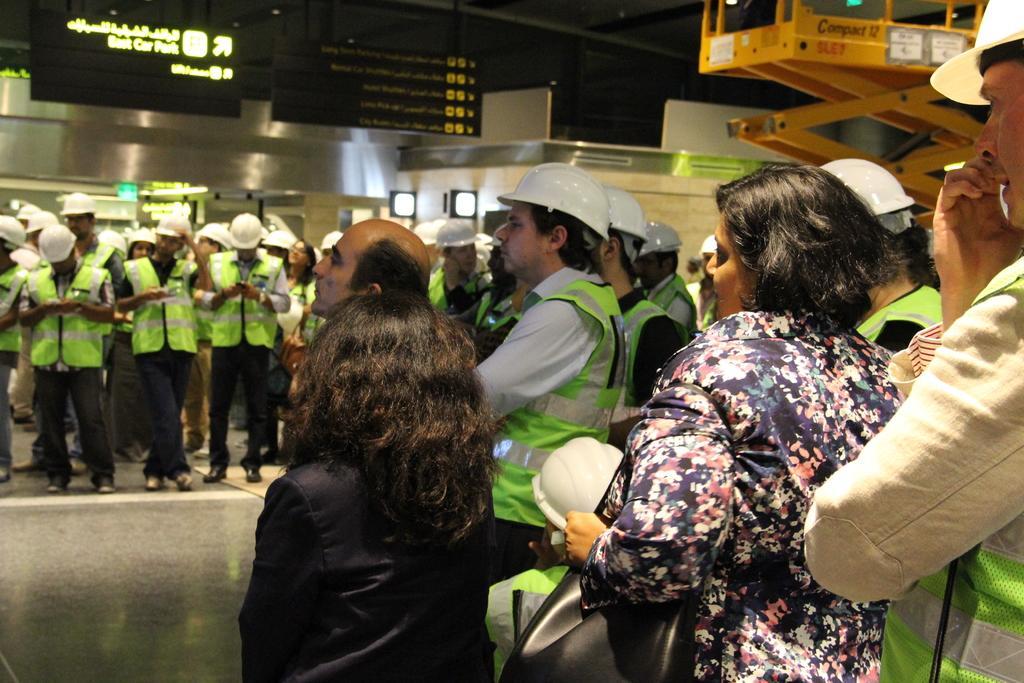Please provide a concise description of this image. In this image in the front there are persons standing. In the background there is a building and on the top there is a board with some text written on it. On the right side there is an object which is yellow in colour with some text written on it. 